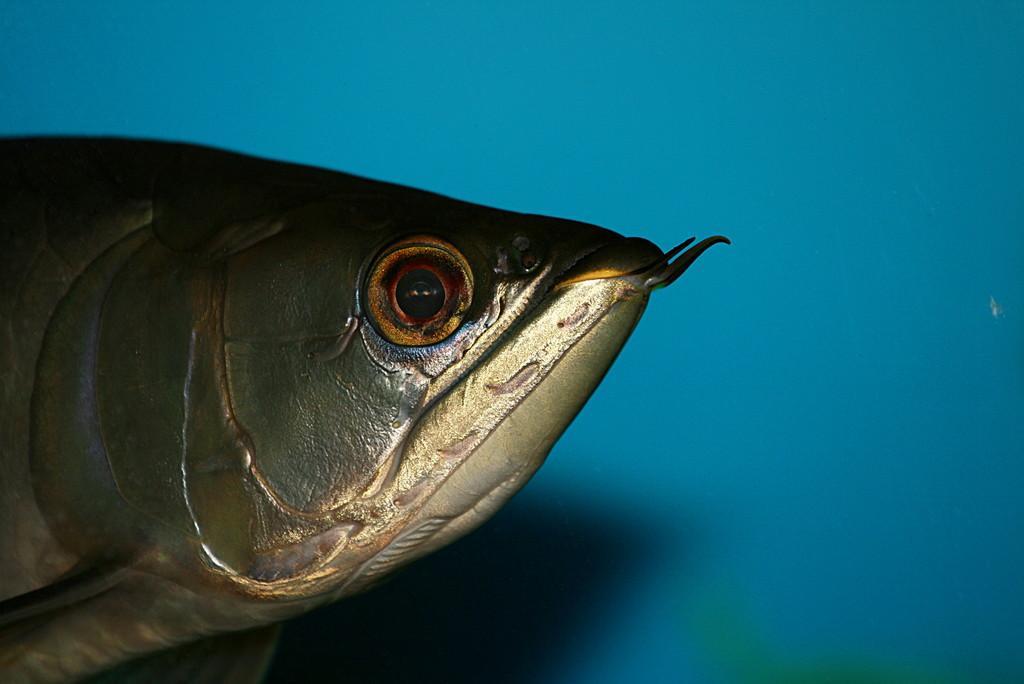Describe this image in one or two sentences. In the picture there is a fish present, beside there is a wall. 